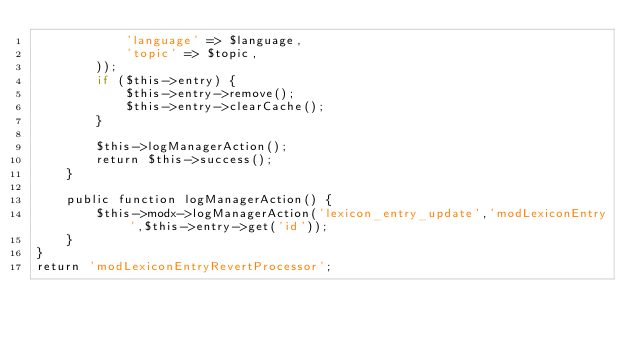Convert code to text. <code><loc_0><loc_0><loc_500><loc_500><_PHP_>            'language' => $language,
            'topic' => $topic,
        ));
        if ($this->entry) {
            $this->entry->remove();
            $this->entry->clearCache();
        }

        $this->logManagerAction();
        return $this->success();
    }

    public function logManagerAction() {
        $this->modx->logManagerAction('lexicon_entry_update','modLexiconEntry',$this->entry->get('id'));
    }
}
return 'modLexiconEntryRevertProcessor';
</code> 